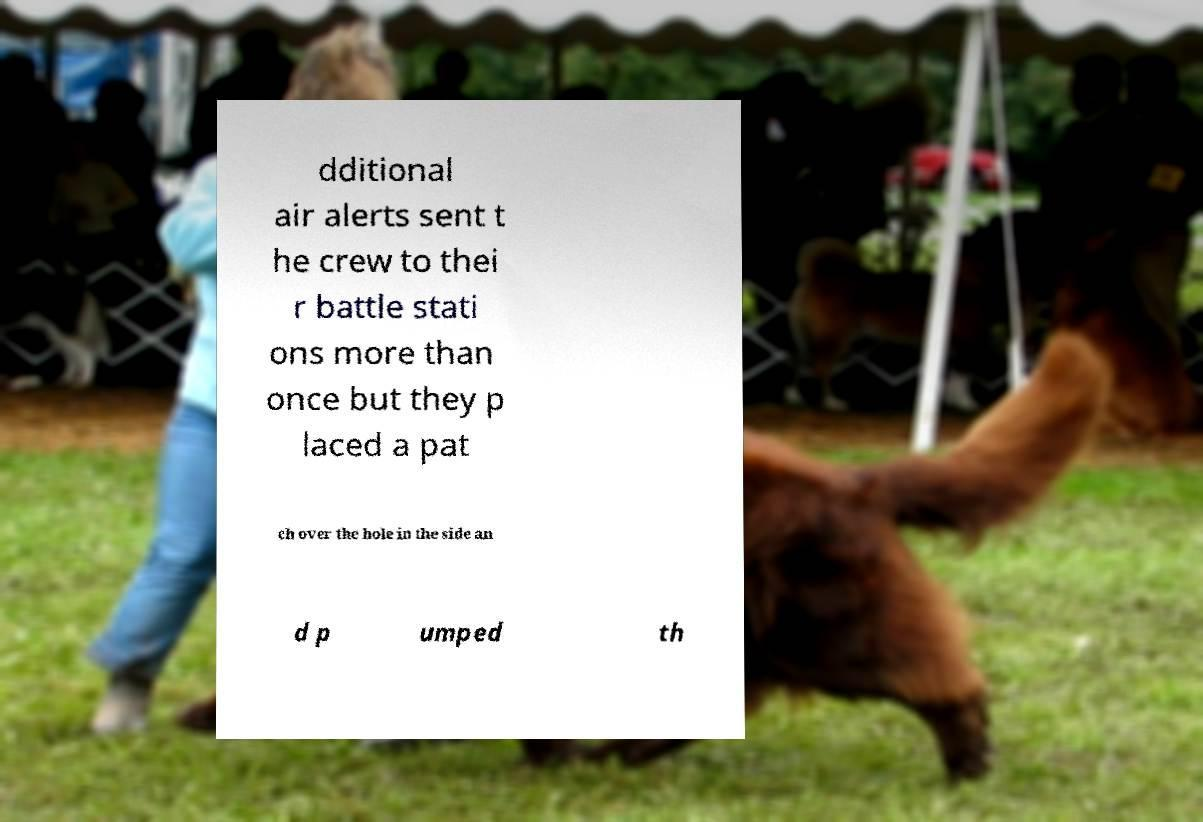There's text embedded in this image that I need extracted. Can you transcribe it verbatim? dditional air alerts sent t he crew to thei r battle stati ons more than once but they p laced a pat ch over the hole in the side an d p umped th 